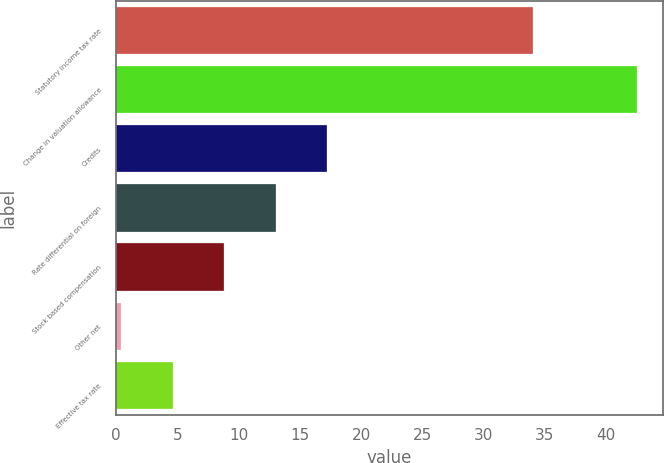Convert chart. <chart><loc_0><loc_0><loc_500><loc_500><bar_chart><fcel>Statutory income tax rate<fcel>Change in valuation allowance<fcel>Credits<fcel>Rate differential on foreign<fcel>Stock based compensation<fcel>Other net<fcel>Effective tax rate<nl><fcel>34<fcel>42.5<fcel>17.24<fcel>13.03<fcel>8.82<fcel>0.4<fcel>4.61<nl></chart> 